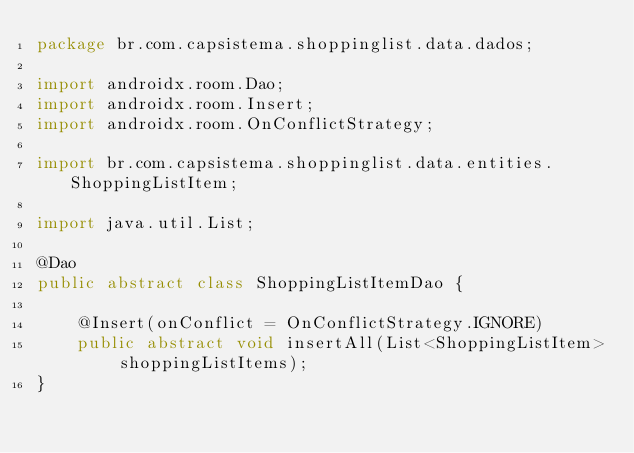<code> <loc_0><loc_0><loc_500><loc_500><_Java_>package br.com.capsistema.shoppinglist.data.dados;

import androidx.room.Dao;
import androidx.room.Insert;
import androidx.room.OnConflictStrategy;

import br.com.capsistema.shoppinglist.data.entities.ShoppingListItem;

import java.util.List;

@Dao
public abstract class ShoppingListItemDao {

    @Insert(onConflict = OnConflictStrategy.IGNORE)
    public abstract void insertAll(List<ShoppingListItem> shoppingListItems);
}
</code> 